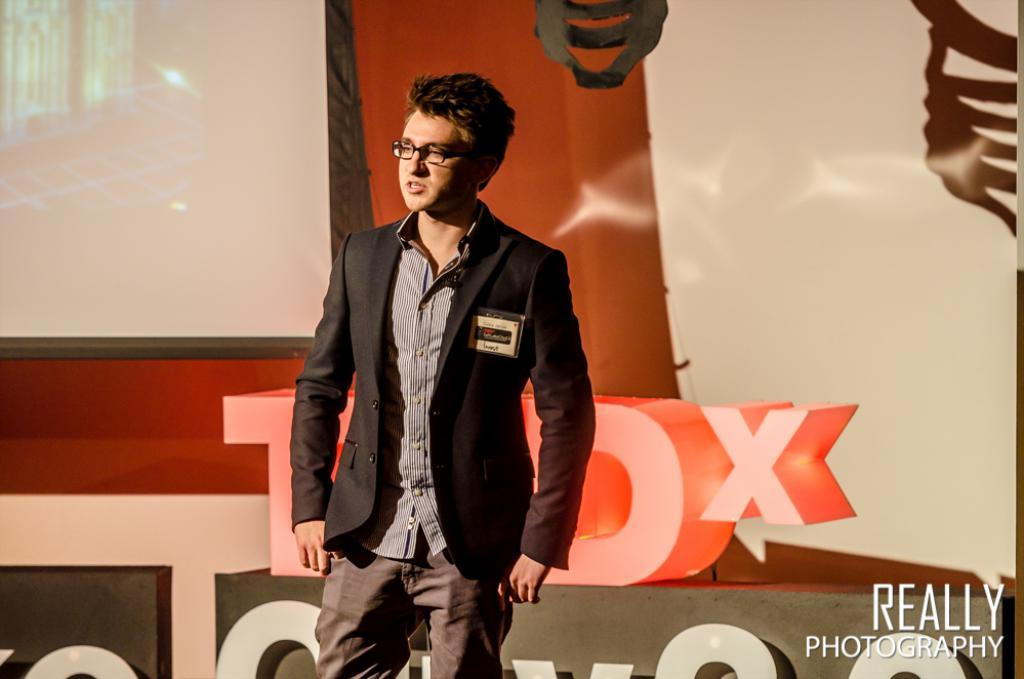What is happening on the stage in the image? There is a person standing on the stage in the image. What can be seen behind the person on the stage? There is a banner behind the person on the stage. What information is provided on the banner? The banner has some text on it. How many frogs are jumping on the chalk in the image? There is no chalk or frogs present in the image. 